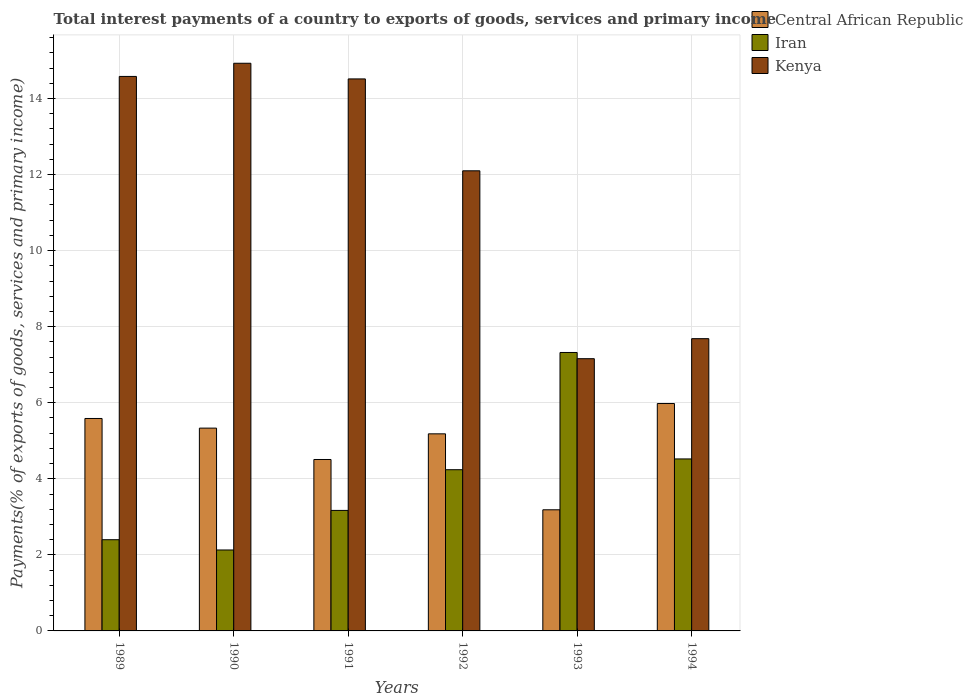Are the number of bars per tick equal to the number of legend labels?
Make the answer very short. Yes. Are the number of bars on each tick of the X-axis equal?
Your answer should be very brief. Yes. What is the total interest payments in Iran in 1989?
Your answer should be compact. 2.4. Across all years, what is the maximum total interest payments in Iran?
Make the answer very short. 7.32. Across all years, what is the minimum total interest payments in Kenya?
Offer a very short reply. 7.16. What is the total total interest payments in Central African Republic in the graph?
Offer a very short reply. 29.77. What is the difference between the total interest payments in Kenya in 1990 and that in 1994?
Offer a terse response. 7.24. What is the difference between the total interest payments in Kenya in 1994 and the total interest payments in Iran in 1990?
Your answer should be very brief. 5.56. What is the average total interest payments in Iran per year?
Keep it short and to the point. 3.96. In the year 1992, what is the difference between the total interest payments in Iran and total interest payments in Central African Republic?
Your answer should be compact. -0.94. In how many years, is the total interest payments in Central African Republic greater than 5.2 %?
Provide a succinct answer. 3. What is the ratio of the total interest payments in Kenya in 1989 to that in 1993?
Your answer should be very brief. 2.04. Is the total interest payments in Kenya in 1989 less than that in 1994?
Your answer should be very brief. No. What is the difference between the highest and the second highest total interest payments in Kenya?
Offer a very short reply. 0.35. What is the difference between the highest and the lowest total interest payments in Kenya?
Offer a very short reply. 7.77. In how many years, is the total interest payments in Central African Republic greater than the average total interest payments in Central African Republic taken over all years?
Make the answer very short. 4. Is the sum of the total interest payments in Central African Republic in 1991 and 1993 greater than the maximum total interest payments in Kenya across all years?
Your answer should be compact. No. What does the 2nd bar from the left in 1992 represents?
Give a very brief answer. Iran. What does the 2nd bar from the right in 1992 represents?
Keep it short and to the point. Iran. How many years are there in the graph?
Offer a terse response. 6. What is the difference between two consecutive major ticks on the Y-axis?
Offer a terse response. 2. Does the graph contain grids?
Give a very brief answer. Yes. Where does the legend appear in the graph?
Keep it short and to the point. Top right. How many legend labels are there?
Offer a very short reply. 3. How are the legend labels stacked?
Provide a short and direct response. Vertical. What is the title of the graph?
Your answer should be compact. Total interest payments of a country to exports of goods, services and primary income. What is the label or title of the Y-axis?
Your answer should be compact. Payments(% of exports of goods, services and primary income). What is the Payments(% of exports of goods, services and primary income) of Central African Republic in 1989?
Your answer should be very brief. 5.59. What is the Payments(% of exports of goods, services and primary income) of Iran in 1989?
Ensure brevity in your answer.  2.4. What is the Payments(% of exports of goods, services and primary income) in Kenya in 1989?
Provide a short and direct response. 14.58. What is the Payments(% of exports of goods, services and primary income) of Central African Republic in 1990?
Offer a terse response. 5.33. What is the Payments(% of exports of goods, services and primary income) of Iran in 1990?
Keep it short and to the point. 2.13. What is the Payments(% of exports of goods, services and primary income) in Kenya in 1990?
Your response must be concise. 14.93. What is the Payments(% of exports of goods, services and primary income) in Central African Republic in 1991?
Provide a short and direct response. 4.51. What is the Payments(% of exports of goods, services and primary income) in Iran in 1991?
Ensure brevity in your answer.  3.17. What is the Payments(% of exports of goods, services and primary income) in Kenya in 1991?
Your answer should be compact. 14.52. What is the Payments(% of exports of goods, services and primary income) in Central African Republic in 1992?
Ensure brevity in your answer.  5.18. What is the Payments(% of exports of goods, services and primary income) of Iran in 1992?
Your response must be concise. 4.24. What is the Payments(% of exports of goods, services and primary income) in Kenya in 1992?
Provide a short and direct response. 12.1. What is the Payments(% of exports of goods, services and primary income) of Central African Republic in 1993?
Provide a short and direct response. 3.19. What is the Payments(% of exports of goods, services and primary income) in Iran in 1993?
Give a very brief answer. 7.32. What is the Payments(% of exports of goods, services and primary income) of Kenya in 1993?
Your answer should be compact. 7.16. What is the Payments(% of exports of goods, services and primary income) in Central African Republic in 1994?
Your response must be concise. 5.98. What is the Payments(% of exports of goods, services and primary income) of Iran in 1994?
Provide a succinct answer. 4.52. What is the Payments(% of exports of goods, services and primary income) in Kenya in 1994?
Offer a terse response. 7.68. Across all years, what is the maximum Payments(% of exports of goods, services and primary income) of Central African Republic?
Give a very brief answer. 5.98. Across all years, what is the maximum Payments(% of exports of goods, services and primary income) of Iran?
Your answer should be compact. 7.32. Across all years, what is the maximum Payments(% of exports of goods, services and primary income) in Kenya?
Make the answer very short. 14.93. Across all years, what is the minimum Payments(% of exports of goods, services and primary income) of Central African Republic?
Provide a succinct answer. 3.19. Across all years, what is the minimum Payments(% of exports of goods, services and primary income) in Iran?
Give a very brief answer. 2.13. Across all years, what is the minimum Payments(% of exports of goods, services and primary income) of Kenya?
Make the answer very short. 7.16. What is the total Payments(% of exports of goods, services and primary income) in Central African Republic in the graph?
Your answer should be compact. 29.77. What is the total Payments(% of exports of goods, services and primary income) of Iran in the graph?
Offer a terse response. 23.78. What is the total Payments(% of exports of goods, services and primary income) of Kenya in the graph?
Give a very brief answer. 70.96. What is the difference between the Payments(% of exports of goods, services and primary income) in Central African Republic in 1989 and that in 1990?
Your answer should be very brief. 0.25. What is the difference between the Payments(% of exports of goods, services and primary income) of Iran in 1989 and that in 1990?
Provide a succinct answer. 0.27. What is the difference between the Payments(% of exports of goods, services and primary income) in Kenya in 1989 and that in 1990?
Offer a very short reply. -0.35. What is the difference between the Payments(% of exports of goods, services and primary income) of Central African Republic in 1989 and that in 1991?
Your answer should be compact. 1.08. What is the difference between the Payments(% of exports of goods, services and primary income) of Iran in 1989 and that in 1991?
Provide a short and direct response. -0.77. What is the difference between the Payments(% of exports of goods, services and primary income) in Kenya in 1989 and that in 1991?
Offer a terse response. 0.07. What is the difference between the Payments(% of exports of goods, services and primary income) of Central African Republic in 1989 and that in 1992?
Make the answer very short. 0.4. What is the difference between the Payments(% of exports of goods, services and primary income) of Iran in 1989 and that in 1992?
Provide a short and direct response. -1.84. What is the difference between the Payments(% of exports of goods, services and primary income) of Kenya in 1989 and that in 1992?
Provide a succinct answer. 2.48. What is the difference between the Payments(% of exports of goods, services and primary income) of Central African Republic in 1989 and that in 1993?
Make the answer very short. 2.4. What is the difference between the Payments(% of exports of goods, services and primary income) in Iran in 1989 and that in 1993?
Keep it short and to the point. -4.92. What is the difference between the Payments(% of exports of goods, services and primary income) in Kenya in 1989 and that in 1993?
Give a very brief answer. 7.42. What is the difference between the Payments(% of exports of goods, services and primary income) of Central African Republic in 1989 and that in 1994?
Keep it short and to the point. -0.39. What is the difference between the Payments(% of exports of goods, services and primary income) in Iran in 1989 and that in 1994?
Keep it short and to the point. -2.12. What is the difference between the Payments(% of exports of goods, services and primary income) in Kenya in 1989 and that in 1994?
Your response must be concise. 6.9. What is the difference between the Payments(% of exports of goods, services and primary income) of Central African Republic in 1990 and that in 1991?
Give a very brief answer. 0.82. What is the difference between the Payments(% of exports of goods, services and primary income) of Iran in 1990 and that in 1991?
Provide a short and direct response. -1.04. What is the difference between the Payments(% of exports of goods, services and primary income) of Kenya in 1990 and that in 1991?
Your answer should be very brief. 0.41. What is the difference between the Payments(% of exports of goods, services and primary income) in Central African Republic in 1990 and that in 1992?
Keep it short and to the point. 0.15. What is the difference between the Payments(% of exports of goods, services and primary income) in Iran in 1990 and that in 1992?
Ensure brevity in your answer.  -2.11. What is the difference between the Payments(% of exports of goods, services and primary income) of Kenya in 1990 and that in 1992?
Give a very brief answer. 2.83. What is the difference between the Payments(% of exports of goods, services and primary income) of Central African Republic in 1990 and that in 1993?
Provide a short and direct response. 2.15. What is the difference between the Payments(% of exports of goods, services and primary income) in Iran in 1990 and that in 1993?
Offer a very short reply. -5.19. What is the difference between the Payments(% of exports of goods, services and primary income) of Kenya in 1990 and that in 1993?
Your response must be concise. 7.77. What is the difference between the Payments(% of exports of goods, services and primary income) in Central African Republic in 1990 and that in 1994?
Provide a short and direct response. -0.65. What is the difference between the Payments(% of exports of goods, services and primary income) of Iran in 1990 and that in 1994?
Give a very brief answer. -2.39. What is the difference between the Payments(% of exports of goods, services and primary income) in Kenya in 1990 and that in 1994?
Your response must be concise. 7.24. What is the difference between the Payments(% of exports of goods, services and primary income) in Central African Republic in 1991 and that in 1992?
Your answer should be very brief. -0.67. What is the difference between the Payments(% of exports of goods, services and primary income) in Iran in 1991 and that in 1992?
Your answer should be compact. -1.07. What is the difference between the Payments(% of exports of goods, services and primary income) in Kenya in 1991 and that in 1992?
Offer a very short reply. 2.42. What is the difference between the Payments(% of exports of goods, services and primary income) of Central African Republic in 1991 and that in 1993?
Make the answer very short. 1.32. What is the difference between the Payments(% of exports of goods, services and primary income) in Iran in 1991 and that in 1993?
Offer a terse response. -4.15. What is the difference between the Payments(% of exports of goods, services and primary income) of Kenya in 1991 and that in 1993?
Give a very brief answer. 7.36. What is the difference between the Payments(% of exports of goods, services and primary income) in Central African Republic in 1991 and that in 1994?
Keep it short and to the point. -1.47. What is the difference between the Payments(% of exports of goods, services and primary income) in Iran in 1991 and that in 1994?
Your response must be concise. -1.35. What is the difference between the Payments(% of exports of goods, services and primary income) in Kenya in 1991 and that in 1994?
Make the answer very short. 6.83. What is the difference between the Payments(% of exports of goods, services and primary income) in Central African Republic in 1992 and that in 1993?
Provide a short and direct response. 2. What is the difference between the Payments(% of exports of goods, services and primary income) in Iran in 1992 and that in 1993?
Give a very brief answer. -3.08. What is the difference between the Payments(% of exports of goods, services and primary income) of Kenya in 1992 and that in 1993?
Ensure brevity in your answer.  4.94. What is the difference between the Payments(% of exports of goods, services and primary income) of Central African Republic in 1992 and that in 1994?
Keep it short and to the point. -0.8. What is the difference between the Payments(% of exports of goods, services and primary income) of Iran in 1992 and that in 1994?
Make the answer very short. -0.28. What is the difference between the Payments(% of exports of goods, services and primary income) in Kenya in 1992 and that in 1994?
Provide a succinct answer. 4.41. What is the difference between the Payments(% of exports of goods, services and primary income) in Central African Republic in 1993 and that in 1994?
Provide a short and direct response. -2.79. What is the difference between the Payments(% of exports of goods, services and primary income) of Iran in 1993 and that in 1994?
Make the answer very short. 2.8. What is the difference between the Payments(% of exports of goods, services and primary income) of Kenya in 1993 and that in 1994?
Your response must be concise. -0.53. What is the difference between the Payments(% of exports of goods, services and primary income) in Central African Republic in 1989 and the Payments(% of exports of goods, services and primary income) in Iran in 1990?
Ensure brevity in your answer.  3.46. What is the difference between the Payments(% of exports of goods, services and primary income) in Central African Republic in 1989 and the Payments(% of exports of goods, services and primary income) in Kenya in 1990?
Your answer should be very brief. -9.34. What is the difference between the Payments(% of exports of goods, services and primary income) of Iran in 1989 and the Payments(% of exports of goods, services and primary income) of Kenya in 1990?
Provide a succinct answer. -12.53. What is the difference between the Payments(% of exports of goods, services and primary income) in Central African Republic in 1989 and the Payments(% of exports of goods, services and primary income) in Iran in 1991?
Provide a succinct answer. 2.42. What is the difference between the Payments(% of exports of goods, services and primary income) of Central African Republic in 1989 and the Payments(% of exports of goods, services and primary income) of Kenya in 1991?
Your response must be concise. -8.93. What is the difference between the Payments(% of exports of goods, services and primary income) of Iran in 1989 and the Payments(% of exports of goods, services and primary income) of Kenya in 1991?
Keep it short and to the point. -12.12. What is the difference between the Payments(% of exports of goods, services and primary income) in Central African Republic in 1989 and the Payments(% of exports of goods, services and primary income) in Iran in 1992?
Keep it short and to the point. 1.35. What is the difference between the Payments(% of exports of goods, services and primary income) in Central African Republic in 1989 and the Payments(% of exports of goods, services and primary income) in Kenya in 1992?
Ensure brevity in your answer.  -6.51. What is the difference between the Payments(% of exports of goods, services and primary income) of Iran in 1989 and the Payments(% of exports of goods, services and primary income) of Kenya in 1992?
Ensure brevity in your answer.  -9.7. What is the difference between the Payments(% of exports of goods, services and primary income) of Central African Republic in 1989 and the Payments(% of exports of goods, services and primary income) of Iran in 1993?
Offer a terse response. -1.74. What is the difference between the Payments(% of exports of goods, services and primary income) of Central African Republic in 1989 and the Payments(% of exports of goods, services and primary income) of Kenya in 1993?
Keep it short and to the point. -1.57. What is the difference between the Payments(% of exports of goods, services and primary income) of Iran in 1989 and the Payments(% of exports of goods, services and primary income) of Kenya in 1993?
Your response must be concise. -4.76. What is the difference between the Payments(% of exports of goods, services and primary income) of Central African Republic in 1989 and the Payments(% of exports of goods, services and primary income) of Iran in 1994?
Provide a short and direct response. 1.06. What is the difference between the Payments(% of exports of goods, services and primary income) in Central African Republic in 1989 and the Payments(% of exports of goods, services and primary income) in Kenya in 1994?
Your answer should be very brief. -2.1. What is the difference between the Payments(% of exports of goods, services and primary income) in Iran in 1989 and the Payments(% of exports of goods, services and primary income) in Kenya in 1994?
Your response must be concise. -5.29. What is the difference between the Payments(% of exports of goods, services and primary income) of Central African Republic in 1990 and the Payments(% of exports of goods, services and primary income) of Iran in 1991?
Your response must be concise. 2.16. What is the difference between the Payments(% of exports of goods, services and primary income) in Central African Republic in 1990 and the Payments(% of exports of goods, services and primary income) in Kenya in 1991?
Keep it short and to the point. -9.18. What is the difference between the Payments(% of exports of goods, services and primary income) in Iran in 1990 and the Payments(% of exports of goods, services and primary income) in Kenya in 1991?
Give a very brief answer. -12.39. What is the difference between the Payments(% of exports of goods, services and primary income) of Central African Republic in 1990 and the Payments(% of exports of goods, services and primary income) of Iran in 1992?
Give a very brief answer. 1.09. What is the difference between the Payments(% of exports of goods, services and primary income) of Central African Republic in 1990 and the Payments(% of exports of goods, services and primary income) of Kenya in 1992?
Make the answer very short. -6.77. What is the difference between the Payments(% of exports of goods, services and primary income) in Iran in 1990 and the Payments(% of exports of goods, services and primary income) in Kenya in 1992?
Your answer should be compact. -9.97. What is the difference between the Payments(% of exports of goods, services and primary income) in Central African Republic in 1990 and the Payments(% of exports of goods, services and primary income) in Iran in 1993?
Your response must be concise. -1.99. What is the difference between the Payments(% of exports of goods, services and primary income) of Central African Republic in 1990 and the Payments(% of exports of goods, services and primary income) of Kenya in 1993?
Give a very brief answer. -1.83. What is the difference between the Payments(% of exports of goods, services and primary income) of Iran in 1990 and the Payments(% of exports of goods, services and primary income) of Kenya in 1993?
Provide a short and direct response. -5.03. What is the difference between the Payments(% of exports of goods, services and primary income) in Central African Republic in 1990 and the Payments(% of exports of goods, services and primary income) in Iran in 1994?
Give a very brief answer. 0.81. What is the difference between the Payments(% of exports of goods, services and primary income) of Central African Republic in 1990 and the Payments(% of exports of goods, services and primary income) of Kenya in 1994?
Provide a short and direct response. -2.35. What is the difference between the Payments(% of exports of goods, services and primary income) in Iran in 1990 and the Payments(% of exports of goods, services and primary income) in Kenya in 1994?
Provide a succinct answer. -5.56. What is the difference between the Payments(% of exports of goods, services and primary income) of Central African Republic in 1991 and the Payments(% of exports of goods, services and primary income) of Iran in 1992?
Your response must be concise. 0.27. What is the difference between the Payments(% of exports of goods, services and primary income) in Central African Republic in 1991 and the Payments(% of exports of goods, services and primary income) in Kenya in 1992?
Offer a very short reply. -7.59. What is the difference between the Payments(% of exports of goods, services and primary income) of Iran in 1991 and the Payments(% of exports of goods, services and primary income) of Kenya in 1992?
Give a very brief answer. -8.93. What is the difference between the Payments(% of exports of goods, services and primary income) in Central African Republic in 1991 and the Payments(% of exports of goods, services and primary income) in Iran in 1993?
Make the answer very short. -2.81. What is the difference between the Payments(% of exports of goods, services and primary income) in Central African Republic in 1991 and the Payments(% of exports of goods, services and primary income) in Kenya in 1993?
Offer a very short reply. -2.65. What is the difference between the Payments(% of exports of goods, services and primary income) in Iran in 1991 and the Payments(% of exports of goods, services and primary income) in Kenya in 1993?
Provide a short and direct response. -3.99. What is the difference between the Payments(% of exports of goods, services and primary income) in Central African Republic in 1991 and the Payments(% of exports of goods, services and primary income) in Iran in 1994?
Keep it short and to the point. -0.01. What is the difference between the Payments(% of exports of goods, services and primary income) in Central African Republic in 1991 and the Payments(% of exports of goods, services and primary income) in Kenya in 1994?
Give a very brief answer. -3.18. What is the difference between the Payments(% of exports of goods, services and primary income) of Iran in 1991 and the Payments(% of exports of goods, services and primary income) of Kenya in 1994?
Make the answer very short. -4.52. What is the difference between the Payments(% of exports of goods, services and primary income) of Central African Republic in 1992 and the Payments(% of exports of goods, services and primary income) of Iran in 1993?
Make the answer very short. -2.14. What is the difference between the Payments(% of exports of goods, services and primary income) in Central African Republic in 1992 and the Payments(% of exports of goods, services and primary income) in Kenya in 1993?
Keep it short and to the point. -1.98. What is the difference between the Payments(% of exports of goods, services and primary income) in Iran in 1992 and the Payments(% of exports of goods, services and primary income) in Kenya in 1993?
Give a very brief answer. -2.92. What is the difference between the Payments(% of exports of goods, services and primary income) in Central African Republic in 1992 and the Payments(% of exports of goods, services and primary income) in Iran in 1994?
Give a very brief answer. 0.66. What is the difference between the Payments(% of exports of goods, services and primary income) of Central African Republic in 1992 and the Payments(% of exports of goods, services and primary income) of Kenya in 1994?
Offer a terse response. -2.5. What is the difference between the Payments(% of exports of goods, services and primary income) of Iran in 1992 and the Payments(% of exports of goods, services and primary income) of Kenya in 1994?
Keep it short and to the point. -3.45. What is the difference between the Payments(% of exports of goods, services and primary income) of Central African Republic in 1993 and the Payments(% of exports of goods, services and primary income) of Iran in 1994?
Make the answer very short. -1.34. What is the difference between the Payments(% of exports of goods, services and primary income) of Central African Republic in 1993 and the Payments(% of exports of goods, services and primary income) of Kenya in 1994?
Your answer should be very brief. -4.5. What is the difference between the Payments(% of exports of goods, services and primary income) in Iran in 1993 and the Payments(% of exports of goods, services and primary income) in Kenya in 1994?
Provide a short and direct response. -0.36. What is the average Payments(% of exports of goods, services and primary income) of Central African Republic per year?
Give a very brief answer. 4.96. What is the average Payments(% of exports of goods, services and primary income) of Iran per year?
Provide a succinct answer. 3.96. What is the average Payments(% of exports of goods, services and primary income) in Kenya per year?
Your response must be concise. 11.83. In the year 1989, what is the difference between the Payments(% of exports of goods, services and primary income) in Central African Republic and Payments(% of exports of goods, services and primary income) in Iran?
Offer a very short reply. 3.19. In the year 1989, what is the difference between the Payments(% of exports of goods, services and primary income) in Central African Republic and Payments(% of exports of goods, services and primary income) in Kenya?
Offer a very short reply. -8.99. In the year 1989, what is the difference between the Payments(% of exports of goods, services and primary income) in Iran and Payments(% of exports of goods, services and primary income) in Kenya?
Offer a very short reply. -12.18. In the year 1990, what is the difference between the Payments(% of exports of goods, services and primary income) of Central African Republic and Payments(% of exports of goods, services and primary income) of Iran?
Ensure brevity in your answer.  3.2. In the year 1990, what is the difference between the Payments(% of exports of goods, services and primary income) of Central African Republic and Payments(% of exports of goods, services and primary income) of Kenya?
Make the answer very short. -9.59. In the year 1990, what is the difference between the Payments(% of exports of goods, services and primary income) in Iran and Payments(% of exports of goods, services and primary income) in Kenya?
Give a very brief answer. -12.8. In the year 1991, what is the difference between the Payments(% of exports of goods, services and primary income) of Central African Republic and Payments(% of exports of goods, services and primary income) of Iran?
Ensure brevity in your answer.  1.34. In the year 1991, what is the difference between the Payments(% of exports of goods, services and primary income) in Central African Republic and Payments(% of exports of goods, services and primary income) in Kenya?
Your response must be concise. -10.01. In the year 1991, what is the difference between the Payments(% of exports of goods, services and primary income) in Iran and Payments(% of exports of goods, services and primary income) in Kenya?
Ensure brevity in your answer.  -11.35. In the year 1992, what is the difference between the Payments(% of exports of goods, services and primary income) of Central African Republic and Payments(% of exports of goods, services and primary income) of Iran?
Your answer should be compact. 0.94. In the year 1992, what is the difference between the Payments(% of exports of goods, services and primary income) of Central African Republic and Payments(% of exports of goods, services and primary income) of Kenya?
Ensure brevity in your answer.  -6.92. In the year 1992, what is the difference between the Payments(% of exports of goods, services and primary income) in Iran and Payments(% of exports of goods, services and primary income) in Kenya?
Keep it short and to the point. -7.86. In the year 1993, what is the difference between the Payments(% of exports of goods, services and primary income) of Central African Republic and Payments(% of exports of goods, services and primary income) of Iran?
Your answer should be very brief. -4.14. In the year 1993, what is the difference between the Payments(% of exports of goods, services and primary income) in Central African Republic and Payments(% of exports of goods, services and primary income) in Kenya?
Provide a short and direct response. -3.97. In the year 1993, what is the difference between the Payments(% of exports of goods, services and primary income) in Iran and Payments(% of exports of goods, services and primary income) in Kenya?
Your answer should be very brief. 0.16. In the year 1994, what is the difference between the Payments(% of exports of goods, services and primary income) of Central African Republic and Payments(% of exports of goods, services and primary income) of Iran?
Make the answer very short. 1.46. In the year 1994, what is the difference between the Payments(% of exports of goods, services and primary income) of Central African Republic and Payments(% of exports of goods, services and primary income) of Kenya?
Your answer should be very brief. -1.71. In the year 1994, what is the difference between the Payments(% of exports of goods, services and primary income) in Iran and Payments(% of exports of goods, services and primary income) in Kenya?
Offer a terse response. -3.16. What is the ratio of the Payments(% of exports of goods, services and primary income) of Central African Republic in 1989 to that in 1990?
Your response must be concise. 1.05. What is the ratio of the Payments(% of exports of goods, services and primary income) in Iran in 1989 to that in 1990?
Your answer should be compact. 1.13. What is the ratio of the Payments(% of exports of goods, services and primary income) of Kenya in 1989 to that in 1990?
Keep it short and to the point. 0.98. What is the ratio of the Payments(% of exports of goods, services and primary income) in Central African Republic in 1989 to that in 1991?
Offer a terse response. 1.24. What is the ratio of the Payments(% of exports of goods, services and primary income) of Iran in 1989 to that in 1991?
Your response must be concise. 0.76. What is the ratio of the Payments(% of exports of goods, services and primary income) in Kenya in 1989 to that in 1991?
Offer a terse response. 1. What is the ratio of the Payments(% of exports of goods, services and primary income) in Central African Republic in 1989 to that in 1992?
Your answer should be compact. 1.08. What is the ratio of the Payments(% of exports of goods, services and primary income) of Iran in 1989 to that in 1992?
Your response must be concise. 0.57. What is the ratio of the Payments(% of exports of goods, services and primary income) in Kenya in 1989 to that in 1992?
Ensure brevity in your answer.  1.21. What is the ratio of the Payments(% of exports of goods, services and primary income) of Central African Republic in 1989 to that in 1993?
Ensure brevity in your answer.  1.75. What is the ratio of the Payments(% of exports of goods, services and primary income) in Iran in 1989 to that in 1993?
Offer a terse response. 0.33. What is the ratio of the Payments(% of exports of goods, services and primary income) of Kenya in 1989 to that in 1993?
Offer a terse response. 2.04. What is the ratio of the Payments(% of exports of goods, services and primary income) in Central African Republic in 1989 to that in 1994?
Ensure brevity in your answer.  0.93. What is the ratio of the Payments(% of exports of goods, services and primary income) of Iran in 1989 to that in 1994?
Your response must be concise. 0.53. What is the ratio of the Payments(% of exports of goods, services and primary income) in Kenya in 1989 to that in 1994?
Make the answer very short. 1.9. What is the ratio of the Payments(% of exports of goods, services and primary income) of Central African Republic in 1990 to that in 1991?
Offer a very short reply. 1.18. What is the ratio of the Payments(% of exports of goods, services and primary income) of Iran in 1990 to that in 1991?
Provide a succinct answer. 0.67. What is the ratio of the Payments(% of exports of goods, services and primary income) in Kenya in 1990 to that in 1991?
Give a very brief answer. 1.03. What is the ratio of the Payments(% of exports of goods, services and primary income) in Central African Republic in 1990 to that in 1992?
Keep it short and to the point. 1.03. What is the ratio of the Payments(% of exports of goods, services and primary income) of Iran in 1990 to that in 1992?
Provide a short and direct response. 0.5. What is the ratio of the Payments(% of exports of goods, services and primary income) in Kenya in 1990 to that in 1992?
Keep it short and to the point. 1.23. What is the ratio of the Payments(% of exports of goods, services and primary income) of Central African Republic in 1990 to that in 1993?
Provide a succinct answer. 1.67. What is the ratio of the Payments(% of exports of goods, services and primary income) of Iran in 1990 to that in 1993?
Provide a short and direct response. 0.29. What is the ratio of the Payments(% of exports of goods, services and primary income) in Kenya in 1990 to that in 1993?
Your answer should be compact. 2.09. What is the ratio of the Payments(% of exports of goods, services and primary income) in Central African Republic in 1990 to that in 1994?
Provide a succinct answer. 0.89. What is the ratio of the Payments(% of exports of goods, services and primary income) in Iran in 1990 to that in 1994?
Provide a succinct answer. 0.47. What is the ratio of the Payments(% of exports of goods, services and primary income) of Kenya in 1990 to that in 1994?
Your answer should be very brief. 1.94. What is the ratio of the Payments(% of exports of goods, services and primary income) in Central African Republic in 1991 to that in 1992?
Your answer should be very brief. 0.87. What is the ratio of the Payments(% of exports of goods, services and primary income) of Iran in 1991 to that in 1992?
Offer a very short reply. 0.75. What is the ratio of the Payments(% of exports of goods, services and primary income) of Kenya in 1991 to that in 1992?
Give a very brief answer. 1.2. What is the ratio of the Payments(% of exports of goods, services and primary income) in Central African Republic in 1991 to that in 1993?
Offer a very short reply. 1.42. What is the ratio of the Payments(% of exports of goods, services and primary income) of Iran in 1991 to that in 1993?
Your answer should be very brief. 0.43. What is the ratio of the Payments(% of exports of goods, services and primary income) of Kenya in 1991 to that in 1993?
Your response must be concise. 2.03. What is the ratio of the Payments(% of exports of goods, services and primary income) of Central African Republic in 1991 to that in 1994?
Offer a terse response. 0.75. What is the ratio of the Payments(% of exports of goods, services and primary income) in Iran in 1991 to that in 1994?
Make the answer very short. 0.7. What is the ratio of the Payments(% of exports of goods, services and primary income) of Kenya in 1991 to that in 1994?
Your response must be concise. 1.89. What is the ratio of the Payments(% of exports of goods, services and primary income) in Central African Republic in 1992 to that in 1993?
Your response must be concise. 1.63. What is the ratio of the Payments(% of exports of goods, services and primary income) of Iran in 1992 to that in 1993?
Your response must be concise. 0.58. What is the ratio of the Payments(% of exports of goods, services and primary income) of Kenya in 1992 to that in 1993?
Your answer should be compact. 1.69. What is the ratio of the Payments(% of exports of goods, services and primary income) in Central African Republic in 1992 to that in 1994?
Give a very brief answer. 0.87. What is the ratio of the Payments(% of exports of goods, services and primary income) of Iran in 1992 to that in 1994?
Give a very brief answer. 0.94. What is the ratio of the Payments(% of exports of goods, services and primary income) of Kenya in 1992 to that in 1994?
Provide a succinct answer. 1.57. What is the ratio of the Payments(% of exports of goods, services and primary income) in Central African Republic in 1993 to that in 1994?
Keep it short and to the point. 0.53. What is the ratio of the Payments(% of exports of goods, services and primary income) in Iran in 1993 to that in 1994?
Make the answer very short. 1.62. What is the ratio of the Payments(% of exports of goods, services and primary income) of Kenya in 1993 to that in 1994?
Provide a succinct answer. 0.93. What is the difference between the highest and the second highest Payments(% of exports of goods, services and primary income) of Central African Republic?
Give a very brief answer. 0.39. What is the difference between the highest and the second highest Payments(% of exports of goods, services and primary income) in Iran?
Your response must be concise. 2.8. What is the difference between the highest and the second highest Payments(% of exports of goods, services and primary income) of Kenya?
Your answer should be very brief. 0.35. What is the difference between the highest and the lowest Payments(% of exports of goods, services and primary income) in Central African Republic?
Provide a short and direct response. 2.79. What is the difference between the highest and the lowest Payments(% of exports of goods, services and primary income) of Iran?
Your answer should be compact. 5.19. What is the difference between the highest and the lowest Payments(% of exports of goods, services and primary income) in Kenya?
Keep it short and to the point. 7.77. 